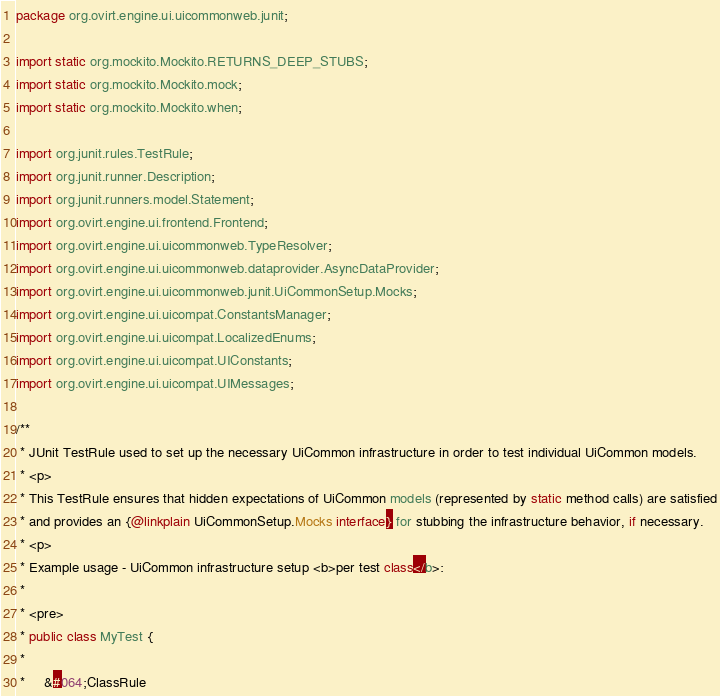Convert code to text. <code><loc_0><loc_0><loc_500><loc_500><_Java_>package org.ovirt.engine.ui.uicommonweb.junit;

import static org.mockito.Mockito.RETURNS_DEEP_STUBS;
import static org.mockito.Mockito.mock;
import static org.mockito.Mockito.when;

import org.junit.rules.TestRule;
import org.junit.runner.Description;
import org.junit.runners.model.Statement;
import org.ovirt.engine.ui.frontend.Frontend;
import org.ovirt.engine.ui.uicommonweb.TypeResolver;
import org.ovirt.engine.ui.uicommonweb.dataprovider.AsyncDataProvider;
import org.ovirt.engine.ui.uicommonweb.junit.UiCommonSetup.Mocks;
import org.ovirt.engine.ui.uicompat.ConstantsManager;
import org.ovirt.engine.ui.uicompat.LocalizedEnums;
import org.ovirt.engine.ui.uicompat.UIConstants;
import org.ovirt.engine.ui.uicompat.UIMessages;

/**
 * JUnit TestRule used to set up the necessary UiCommon infrastructure in order to test individual UiCommon models.
 * <p>
 * This TestRule ensures that hidden expectations of UiCommon models (represented by static method calls) are satisfied
 * and provides an {@linkplain UiCommonSetup.Mocks interface} for stubbing the infrastructure behavior, if necessary.
 * <p>
 * Example usage - UiCommon infrastructure setup <b>per test class</b>:
 *
 * <pre>
 * public class MyTest {
 *
 *     &#064;ClassRule</code> 